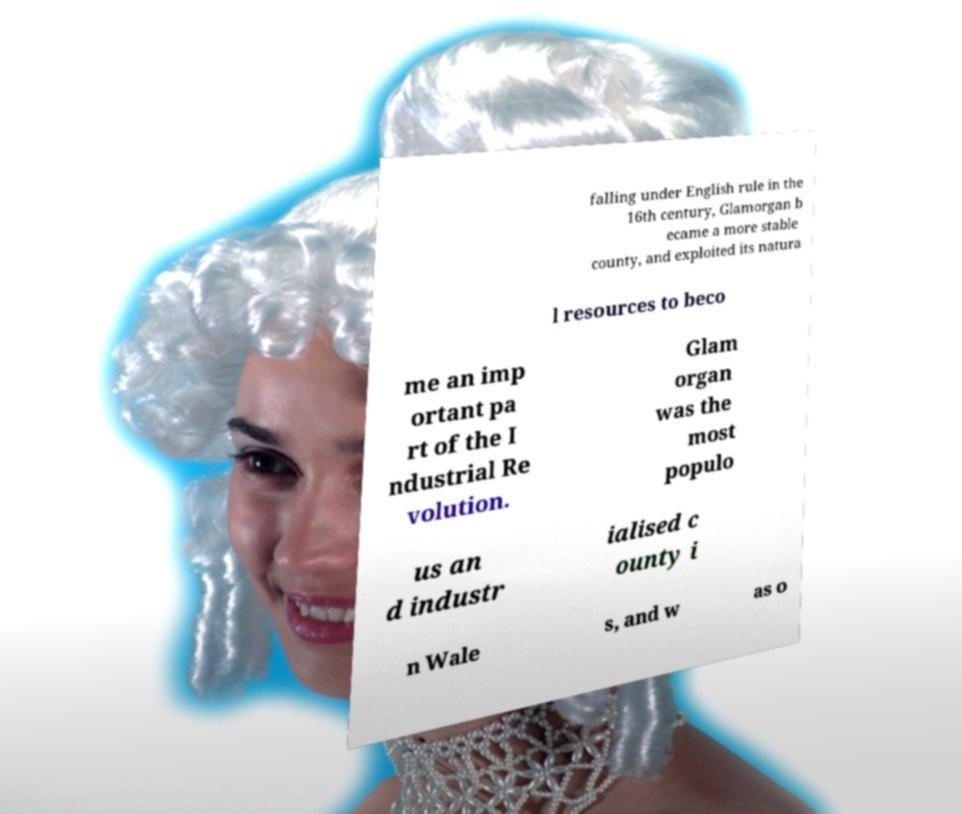What messages or text are displayed in this image? I need them in a readable, typed format. falling under English rule in the 16th century, Glamorgan b ecame a more stable county, and exploited its natura l resources to beco me an imp ortant pa rt of the I ndustrial Re volution. Glam organ was the most populo us an d industr ialised c ounty i n Wale s, and w as o 